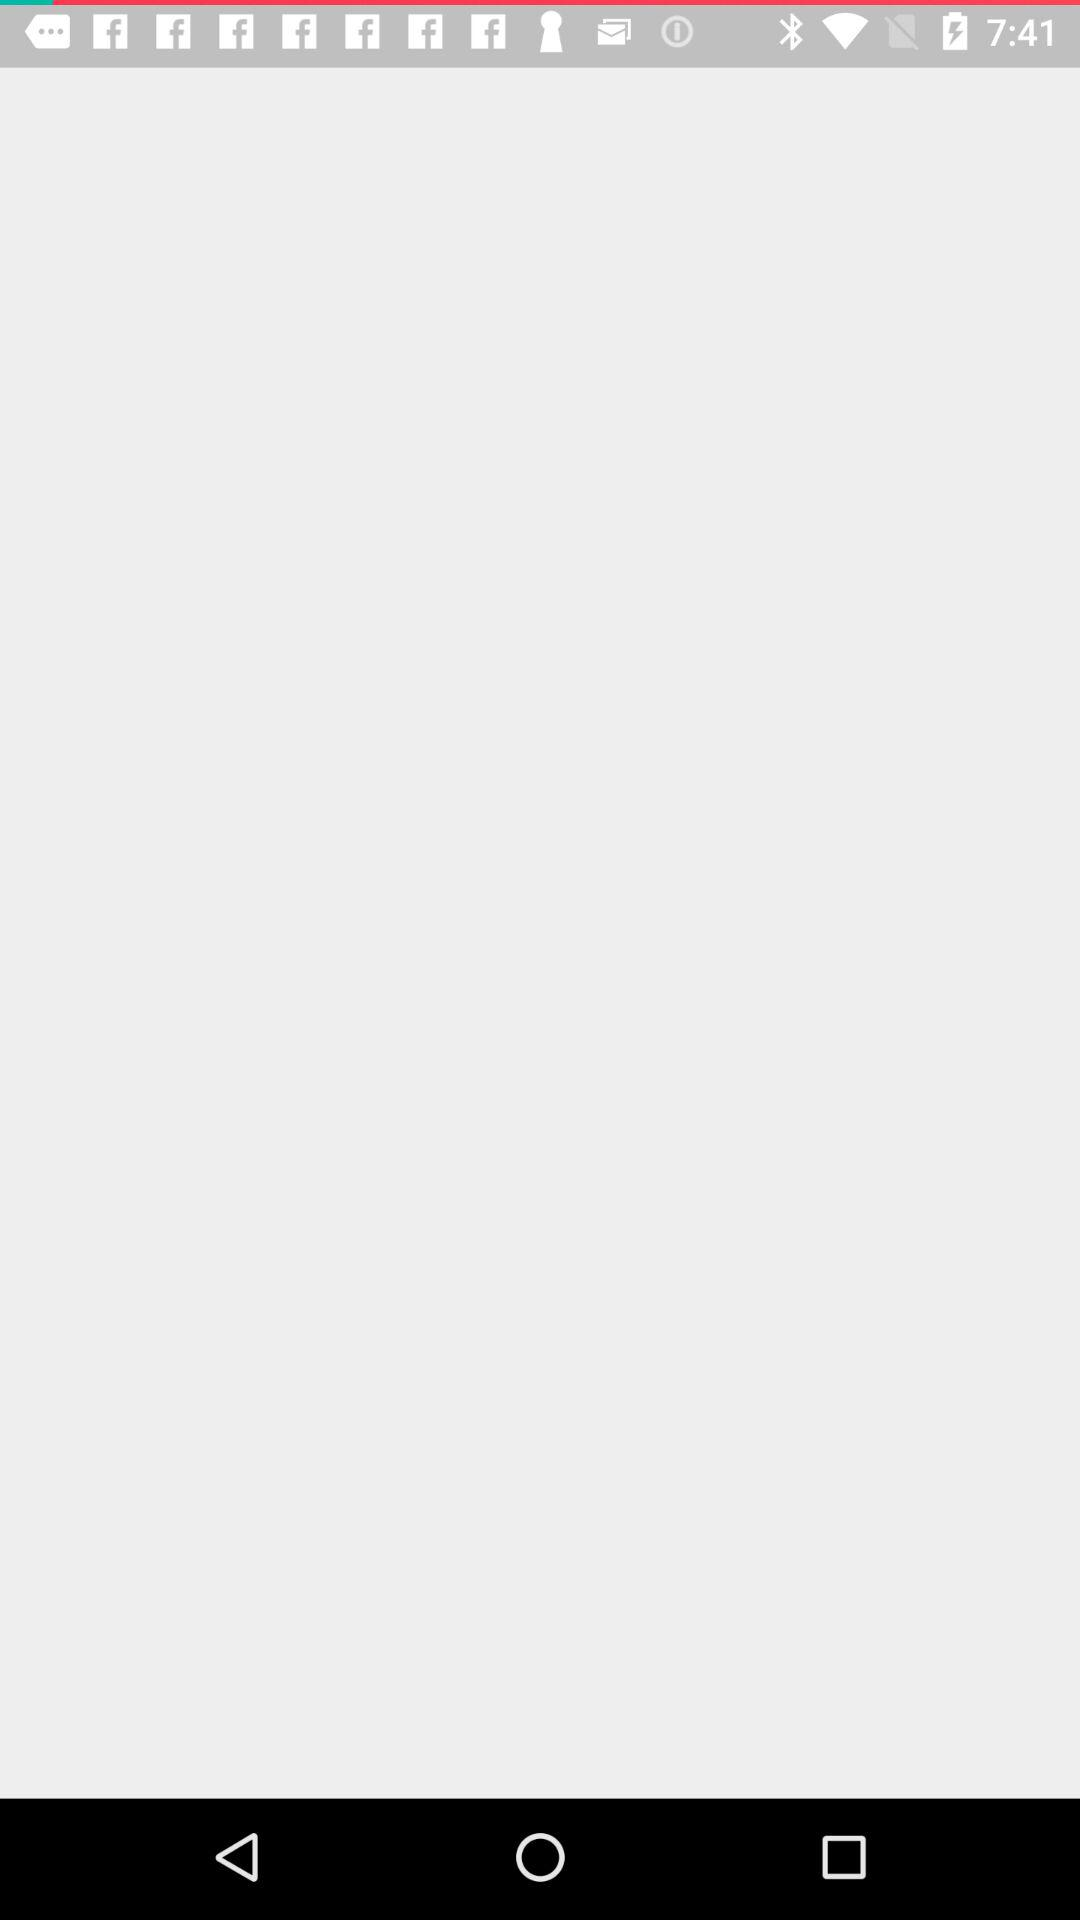Through which applications can we open it? You can open it through "Play Store" and "Browser". 